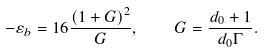<formula> <loc_0><loc_0><loc_500><loc_500>- \varepsilon _ { b } = 1 6 \frac { \left ( 1 + G \right ) ^ { 2 } } { G } , \quad G = \frac { d _ { 0 } + 1 } { d _ { 0 } \Gamma } .</formula> 